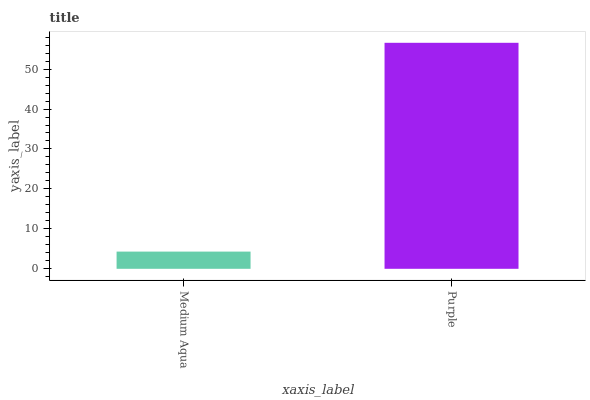Is Purple the minimum?
Answer yes or no. No. Is Purple greater than Medium Aqua?
Answer yes or no. Yes. Is Medium Aqua less than Purple?
Answer yes or no. Yes. Is Medium Aqua greater than Purple?
Answer yes or no. No. Is Purple less than Medium Aqua?
Answer yes or no. No. Is Purple the high median?
Answer yes or no. Yes. Is Medium Aqua the low median?
Answer yes or no. Yes. Is Medium Aqua the high median?
Answer yes or no. No. Is Purple the low median?
Answer yes or no. No. 